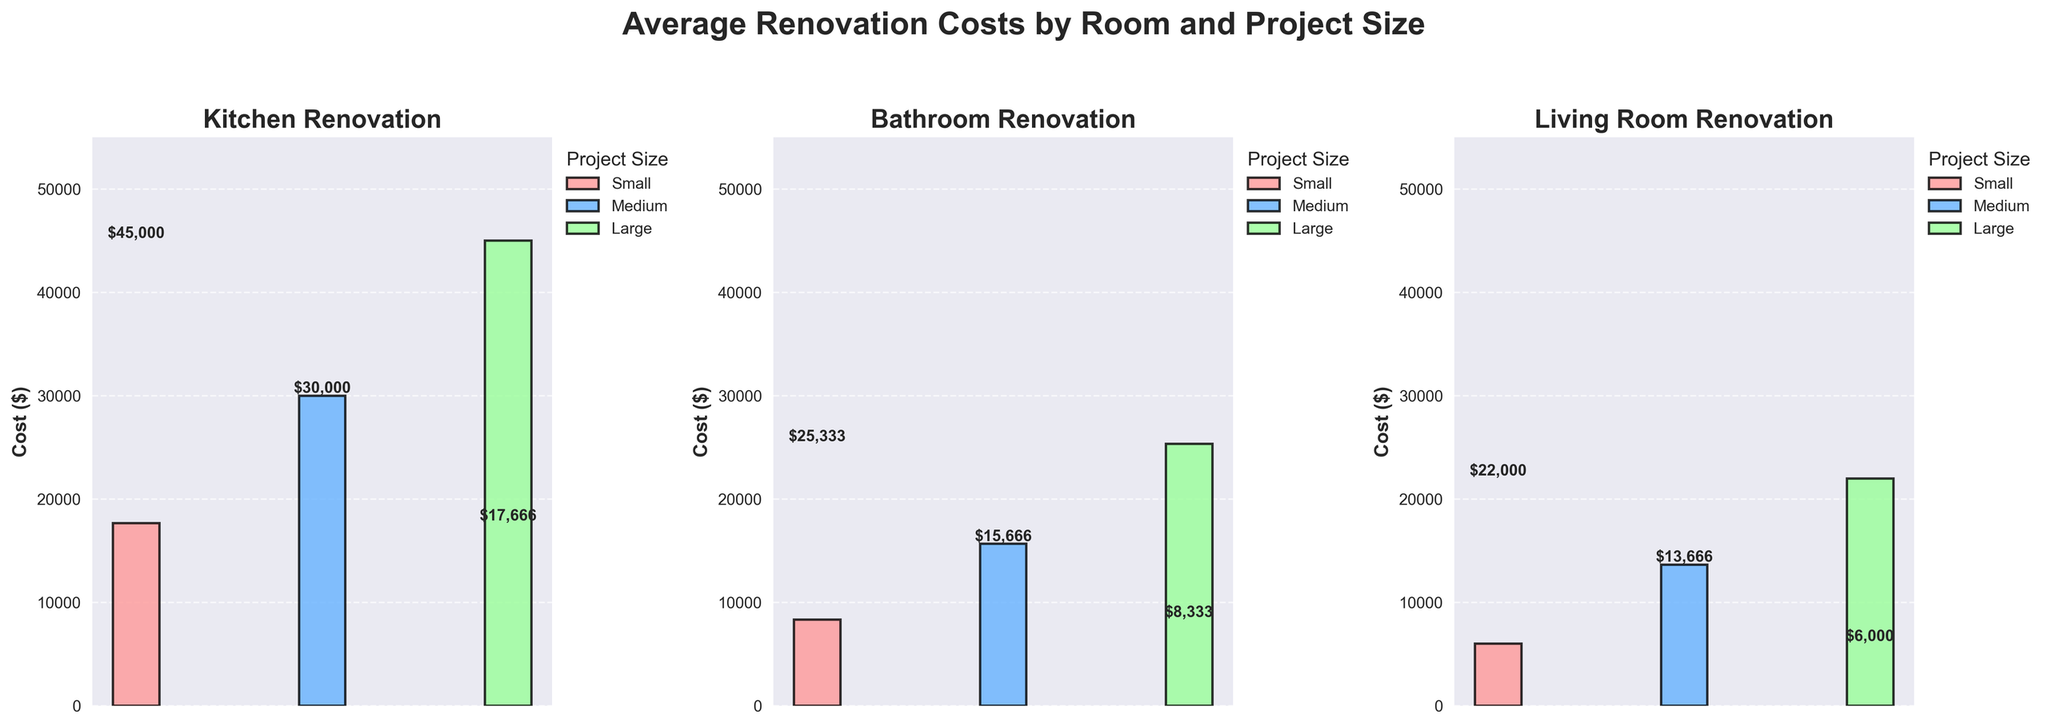Which room has the highest average renovation cost for small projects? To determine which room has the highest average renovation cost for small projects, look at the heights of the bars labeled 'Small' under each room subplot. The room with the tallest bar represents the highest average cost.
Answer: Kitchen What is the average renovation cost for medium-sized bathroom projects? Find the medium-sized bar in the bathroom subplot and read the height value labeled near the top of the bar. This value represents the average cost.
Answer: 15,000 Which project size has the smallest average renovation cost in the living room category? To find the project size with the smallest average cost in the living room category, look at the bars in the living room subplot and compare their heights. The shortest bar represents the smallest average cost.
Answer: Small Rank the rooms from highest to lowest average cost for large projects. For large projects, check the heights of the bars labeled 'Large' in each room subplot. Arrange the rooms by the height of these bars in descending order: Kitchen, Bathroom, Living Room.
Answer: Kitchen, Bathroom, Living Room 